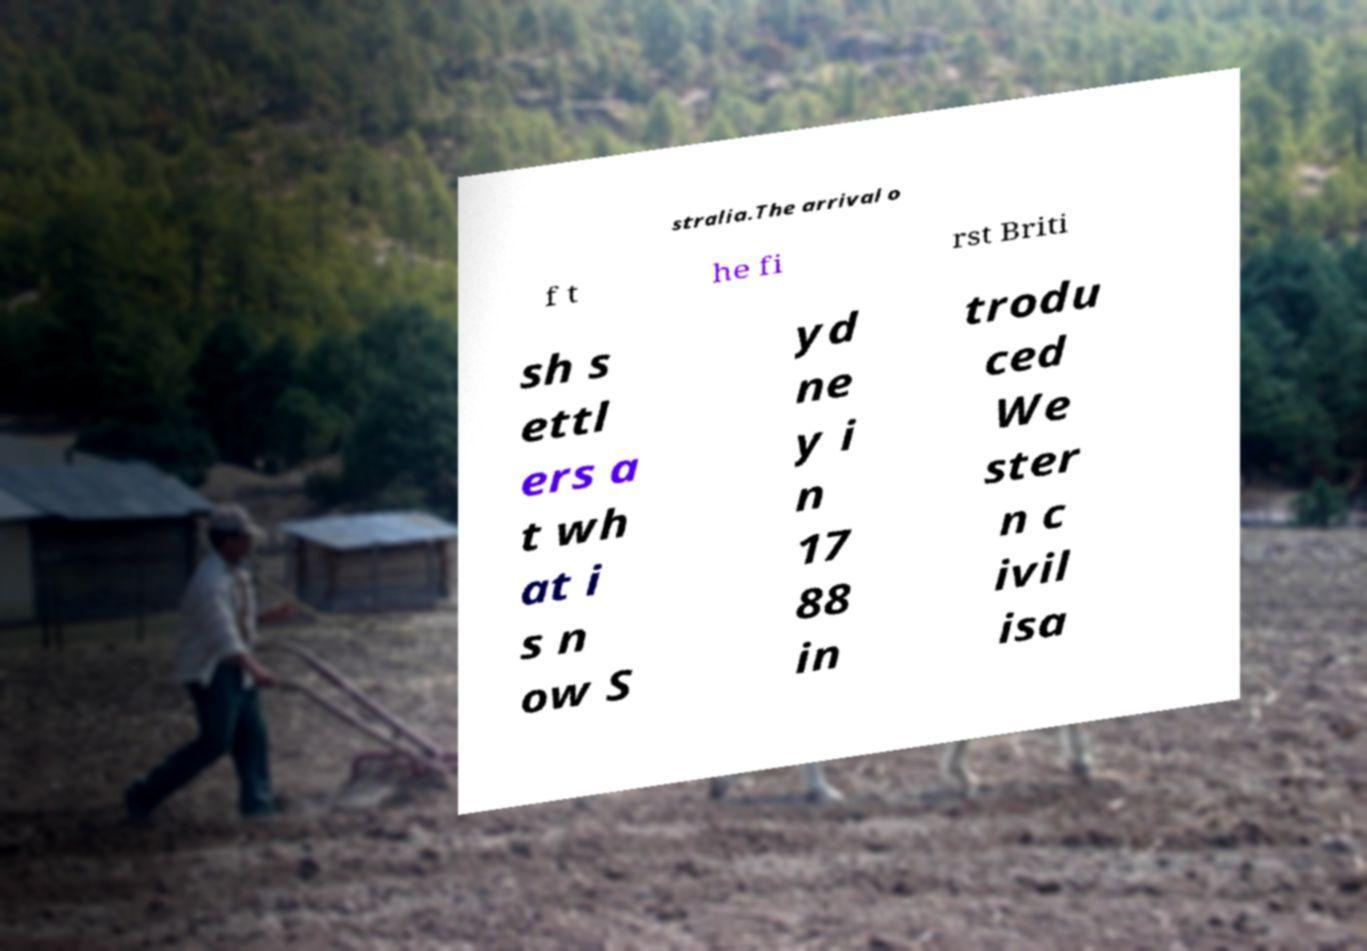Please read and relay the text visible in this image. What does it say? stralia.The arrival o f t he fi rst Briti sh s ettl ers a t wh at i s n ow S yd ne y i n 17 88 in trodu ced We ster n c ivil isa 